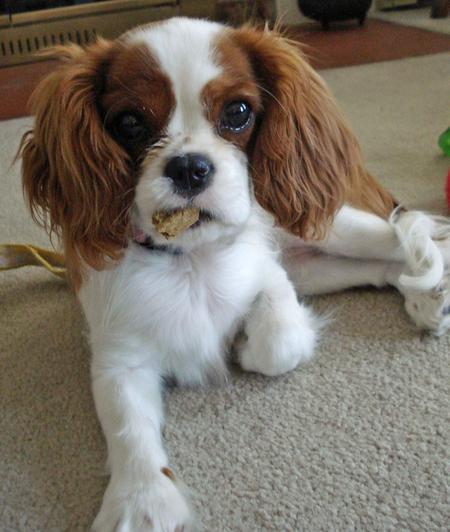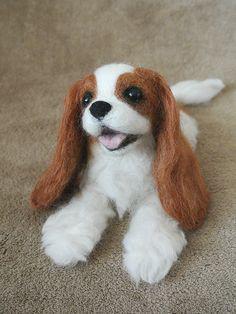The first image is the image on the left, the second image is the image on the right. For the images shown, is this caption "One of the images contains a dog that is standing." true? Answer yes or no. No. 